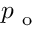<formula> <loc_0><loc_0><loc_500><loc_500>p _ { o }</formula> 